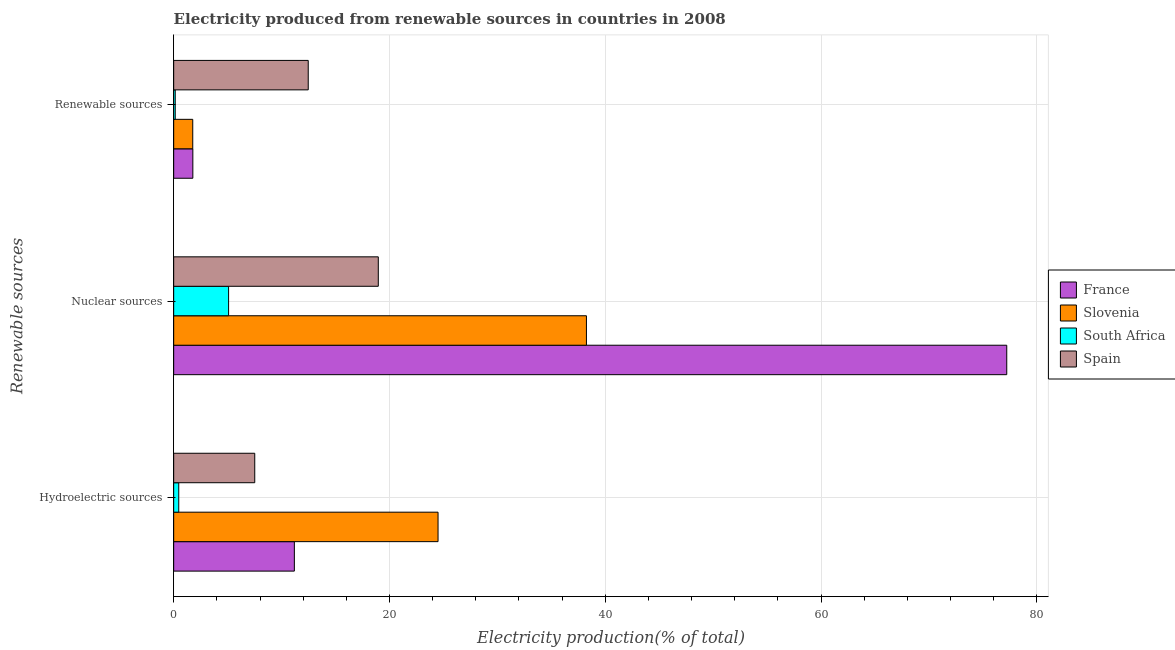How many different coloured bars are there?
Provide a short and direct response. 4. How many groups of bars are there?
Make the answer very short. 3. Are the number of bars per tick equal to the number of legend labels?
Your answer should be very brief. Yes. Are the number of bars on each tick of the Y-axis equal?
Ensure brevity in your answer.  Yes. How many bars are there on the 3rd tick from the bottom?
Give a very brief answer. 4. What is the label of the 3rd group of bars from the top?
Keep it short and to the point. Hydroelectric sources. What is the percentage of electricity produced by hydroelectric sources in France?
Offer a very short reply. 11.18. Across all countries, what is the maximum percentage of electricity produced by renewable sources?
Your answer should be very brief. 12.47. Across all countries, what is the minimum percentage of electricity produced by hydroelectric sources?
Your answer should be compact. 0.47. In which country was the percentage of electricity produced by nuclear sources maximum?
Keep it short and to the point. France. In which country was the percentage of electricity produced by nuclear sources minimum?
Offer a very short reply. South Africa. What is the total percentage of electricity produced by hydroelectric sources in the graph?
Offer a terse response. 43.67. What is the difference between the percentage of electricity produced by renewable sources in Slovenia and that in France?
Your answer should be very brief. -0.01. What is the difference between the percentage of electricity produced by nuclear sources in Slovenia and the percentage of electricity produced by renewable sources in France?
Keep it short and to the point. 36.48. What is the average percentage of electricity produced by hydroelectric sources per country?
Keep it short and to the point. 10.92. What is the difference between the percentage of electricity produced by hydroelectric sources and percentage of electricity produced by renewable sources in France?
Provide a short and direct response. 9.41. What is the ratio of the percentage of electricity produced by hydroelectric sources in South Africa to that in Slovenia?
Provide a succinct answer. 0.02. Is the difference between the percentage of electricity produced by renewable sources in Spain and France greater than the difference between the percentage of electricity produced by hydroelectric sources in Spain and France?
Provide a short and direct response. Yes. What is the difference between the highest and the second highest percentage of electricity produced by hydroelectric sources?
Your response must be concise. 13.32. What is the difference between the highest and the lowest percentage of electricity produced by renewable sources?
Offer a terse response. 12.33. In how many countries, is the percentage of electricity produced by hydroelectric sources greater than the average percentage of electricity produced by hydroelectric sources taken over all countries?
Give a very brief answer. 2. Is the sum of the percentage of electricity produced by renewable sources in South Africa and France greater than the maximum percentage of electricity produced by nuclear sources across all countries?
Your answer should be very brief. No. What does the 4th bar from the top in Hydroelectric sources represents?
Your response must be concise. France. Is it the case that in every country, the sum of the percentage of electricity produced by hydroelectric sources and percentage of electricity produced by nuclear sources is greater than the percentage of electricity produced by renewable sources?
Keep it short and to the point. Yes. Are all the bars in the graph horizontal?
Your response must be concise. Yes. What is the difference between two consecutive major ticks on the X-axis?
Your answer should be very brief. 20. Does the graph contain grids?
Make the answer very short. Yes. Where does the legend appear in the graph?
Ensure brevity in your answer.  Center right. How are the legend labels stacked?
Your response must be concise. Vertical. What is the title of the graph?
Offer a very short reply. Electricity produced from renewable sources in countries in 2008. What is the label or title of the Y-axis?
Ensure brevity in your answer.  Renewable sources. What is the Electricity production(% of total) of France in Hydroelectric sources?
Your answer should be very brief. 11.18. What is the Electricity production(% of total) in Slovenia in Hydroelectric sources?
Provide a succinct answer. 24.5. What is the Electricity production(% of total) in South Africa in Hydroelectric sources?
Offer a terse response. 0.47. What is the Electricity production(% of total) of Spain in Hydroelectric sources?
Ensure brevity in your answer.  7.51. What is the Electricity production(% of total) of France in Nuclear sources?
Offer a very short reply. 77.21. What is the Electricity production(% of total) in Slovenia in Nuclear sources?
Your answer should be very brief. 38.25. What is the Electricity production(% of total) of South Africa in Nuclear sources?
Your answer should be compact. 5.09. What is the Electricity production(% of total) of Spain in Nuclear sources?
Your answer should be very brief. 18.96. What is the Electricity production(% of total) of France in Renewable sources?
Make the answer very short. 1.78. What is the Electricity production(% of total) of Slovenia in Renewable sources?
Provide a succinct answer. 1.77. What is the Electricity production(% of total) in South Africa in Renewable sources?
Offer a very short reply. 0.14. What is the Electricity production(% of total) in Spain in Renewable sources?
Keep it short and to the point. 12.47. Across all Renewable sources, what is the maximum Electricity production(% of total) of France?
Provide a short and direct response. 77.21. Across all Renewable sources, what is the maximum Electricity production(% of total) of Slovenia?
Offer a very short reply. 38.25. Across all Renewable sources, what is the maximum Electricity production(% of total) of South Africa?
Make the answer very short. 5.09. Across all Renewable sources, what is the maximum Electricity production(% of total) of Spain?
Provide a succinct answer. 18.96. Across all Renewable sources, what is the minimum Electricity production(% of total) of France?
Ensure brevity in your answer.  1.78. Across all Renewable sources, what is the minimum Electricity production(% of total) of Slovenia?
Your answer should be compact. 1.77. Across all Renewable sources, what is the minimum Electricity production(% of total) of South Africa?
Your answer should be compact. 0.14. Across all Renewable sources, what is the minimum Electricity production(% of total) in Spain?
Give a very brief answer. 7.51. What is the total Electricity production(% of total) in France in the graph?
Your answer should be very brief. 90.17. What is the total Electricity production(% of total) of Slovenia in the graph?
Your answer should be compact. 64.52. What is the total Electricity production(% of total) in South Africa in the graph?
Offer a terse response. 5.7. What is the total Electricity production(% of total) of Spain in the graph?
Offer a terse response. 38.95. What is the difference between the Electricity production(% of total) in France in Hydroelectric sources and that in Nuclear sources?
Provide a succinct answer. -66.02. What is the difference between the Electricity production(% of total) of Slovenia in Hydroelectric sources and that in Nuclear sources?
Your answer should be compact. -13.75. What is the difference between the Electricity production(% of total) in South Africa in Hydroelectric sources and that in Nuclear sources?
Keep it short and to the point. -4.62. What is the difference between the Electricity production(% of total) in Spain in Hydroelectric sources and that in Nuclear sources?
Your answer should be compact. -11.45. What is the difference between the Electricity production(% of total) in France in Hydroelectric sources and that in Renewable sources?
Keep it short and to the point. 9.41. What is the difference between the Electricity production(% of total) in Slovenia in Hydroelectric sources and that in Renewable sources?
Offer a terse response. 22.73. What is the difference between the Electricity production(% of total) of South Africa in Hydroelectric sources and that in Renewable sources?
Your answer should be compact. 0.33. What is the difference between the Electricity production(% of total) of Spain in Hydroelectric sources and that in Renewable sources?
Your answer should be very brief. -4.96. What is the difference between the Electricity production(% of total) of France in Nuclear sources and that in Renewable sources?
Give a very brief answer. 75.43. What is the difference between the Electricity production(% of total) in Slovenia in Nuclear sources and that in Renewable sources?
Your response must be concise. 36.48. What is the difference between the Electricity production(% of total) of South Africa in Nuclear sources and that in Renewable sources?
Your answer should be very brief. 4.94. What is the difference between the Electricity production(% of total) in Spain in Nuclear sources and that in Renewable sources?
Make the answer very short. 6.49. What is the difference between the Electricity production(% of total) of France in Hydroelectric sources and the Electricity production(% of total) of Slovenia in Nuclear sources?
Offer a very short reply. -27.07. What is the difference between the Electricity production(% of total) of France in Hydroelectric sources and the Electricity production(% of total) of South Africa in Nuclear sources?
Give a very brief answer. 6.09. What is the difference between the Electricity production(% of total) of France in Hydroelectric sources and the Electricity production(% of total) of Spain in Nuclear sources?
Offer a very short reply. -7.78. What is the difference between the Electricity production(% of total) of Slovenia in Hydroelectric sources and the Electricity production(% of total) of South Africa in Nuclear sources?
Your response must be concise. 19.41. What is the difference between the Electricity production(% of total) of Slovenia in Hydroelectric sources and the Electricity production(% of total) of Spain in Nuclear sources?
Your response must be concise. 5.54. What is the difference between the Electricity production(% of total) in South Africa in Hydroelectric sources and the Electricity production(% of total) in Spain in Nuclear sources?
Your answer should be very brief. -18.49. What is the difference between the Electricity production(% of total) in France in Hydroelectric sources and the Electricity production(% of total) in Slovenia in Renewable sources?
Your answer should be very brief. 9.42. What is the difference between the Electricity production(% of total) in France in Hydroelectric sources and the Electricity production(% of total) in South Africa in Renewable sources?
Provide a succinct answer. 11.04. What is the difference between the Electricity production(% of total) of France in Hydroelectric sources and the Electricity production(% of total) of Spain in Renewable sources?
Keep it short and to the point. -1.29. What is the difference between the Electricity production(% of total) in Slovenia in Hydroelectric sources and the Electricity production(% of total) in South Africa in Renewable sources?
Your response must be concise. 24.36. What is the difference between the Electricity production(% of total) in Slovenia in Hydroelectric sources and the Electricity production(% of total) in Spain in Renewable sources?
Provide a short and direct response. 12.03. What is the difference between the Electricity production(% of total) of South Africa in Hydroelectric sources and the Electricity production(% of total) of Spain in Renewable sources?
Provide a short and direct response. -12. What is the difference between the Electricity production(% of total) in France in Nuclear sources and the Electricity production(% of total) in Slovenia in Renewable sources?
Your answer should be compact. 75.44. What is the difference between the Electricity production(% of total) of France in Nuclear sources and the Electricity production(% of total) of South Africa in Renewable sources?
Offer a terse response. 77.06. What is the difference between the Electricity production(% of total) of France in Nuclear sources and the Electricity production(% of total) of Spain in Renewable sources?
Provide a short and direct response. 64.74. What is the difference between the Electricity production(% of total) in Slovenia in Nuclear sources and the Electricity production(% of total) in South Africa in Renewable sources?
Make the answer very short. 38.11. What is the difference between the Electricity production(% of total) in Slovenia in Nuclear sources and the Electricity production(% of total) in Spain in Renewable sources?
Your answer should be compact. 25.78. What is the difference between the Electricity production(% of total) in South Africa in Nuclear sources and the Electricity production(% of total) in Spain in Renewable sources?
Provide a succinct answer. -7.38. What is the average Electricity production(% of total) in France per Renewable sources?
Your response must be concise. 30.06. What is the average Electricity production(% of total) in Slovenia per Renewable sources?
Ensure brevity in your answer.  21.51. What is the average Electricity production(% of total) of South Africa per Renewable sources?
Your response must be concise. 1.9. What is the average Electricity production(% of total) in Spain per Renewable sources?
Provide a succinct answer. 12.98. What is the difference between the Electricity production(% of total) of France and Electricity production(% of total) of Slovenia in Hydroelectric sources?
Your answer should be very brief. -13.32. What is the difference between the Electricity production(% of total) of France and Electricity production(% of total) of South Africa in Hydroelectric sources?
Your answer should be compact. 10.71. What is the difference between the Electricity production(% of total) in France and Electricity production(% of total) in Spain in Hydroelectric sources?
Provide a short and direct response. 3.67. What is the difference between the Electricity production(% of total) in Slovenia and Electricity production(% of total) in South Africa in Hydroelectric sources?
Provide a short and direct response. 24.03. What is the difference between the Electricity production(% of total) in Slovenia and Electricity production(% of total) in Spain in Hydroelectric sources?
Offer a terse response. 16.99. What is the difference between the Electricity production(% of total) of South Africa and Electricity production(% of total) of Spain in Hydroelectric sources?
Keep it short and to the point. -7.04. What is the difference between the Electricity production(% of total) in France and Electricity production(% of total) in Slovenia in Nuclear sources?
Make the answer very short. 38.95. What is the difference between the Electricity production(% of total) in France and Electricity production(% of total) in South Africa in Nuclear sources?
Your answer should be very brief. 72.12. What is the difference between the Electricity production(% of total) of France and Electricity production(% of total) of Spain in Nuclear sources?
Your answer should be very brief. 58.24. What is the difference between the Electricity production(% of total) in Slovenia and Electricity production(% of total) in South Africa in Nuclear sources?
Keep it short and to the point. 33.16. What is the difference between the Electricity production(% of total) in Slovenia and Electricity production(% of total) in Spain in Nuclear sources?
Provide a succinct answer. 19.29. What is the difference between the Electricity production(% of total) in South Africa and Electricity production(% of total) in Spain in Nuclear sources?
Keep it short and to the point. -13.87. What is the difference between the Electricity production(% of total) of France and Electricity production(% of total) of Slovenia in Renewable sources?
Offer a very short reply. 0.01. What is the difference between the Electricity production(% of total) of France and Electricity production(% of total) of South Africa in Renewable sources?
Give a very brief answer. 1.63. What is the difference between the Electricity production(% of total) in France and Electricity production(% of total) in Spain in Renewable sources?
Your answer should be very brief. -10.69. What is the difference between the Electricity production(% of total) in Slovenia and Electricity production(% of total) in South Africa in Renewable sources?
Offer a very short reply. 1.62. What is the difference between the Electricity production(% of total) in Slovenia and Electricity production(% of total) in Spain in Renewable sources?
Make the answer very short. -10.7. What is the difference between the Electricity production(% of total) of South Africa and Electricity production(% of total) of Spain in Renewable sources?
Your answer should be very brief. -12.33. What is the ratio of the Electricity production(% of total) in France in Hydroelectric sources to that in Nuclear sources?
Offer a terse response. 0.14. What is the ratio of the Electricity production(% of total) in Slovenia in Hydroelectric sources to that in Nuclear sources?
Provide a succinct answer. 0.64. What is the ratio of the Electricity production(% of total) in South Africa in Hydroelectric sources to that in Nuclear sources?
Provide a short and direct response. 0.09. What is the ratio of the Electricity production(% of total) of Spain in Hydroelectric sources to that in Nuclear sources?
Provide a short and direct response. 0.4. What is the ratio of the Electricity production(% of total) of France in Hydroelectric sources to that in Renewable sources?
Ensure brevity in your answer.  6.29. What is the ratio of the Electricity production(% of total) in Slovenia in Hydroelectric sources to that in Renewable sources?
Your answer should be very brief. 13.86. What is the ratio of the Electricity production(% of total) in South Africa in Hydroelectric sources to that in Renewable sources?
Your answer should be very brief. 3.26. What is the ratio of the Electricity production(% of total) in Spain in Hydroelectric sources to that in Renewable sources?
Ensure brevity in your answer.  0.6. What is the ratio of the Electricity production(% of total) of France in Nuclear sources to that in Renewable sources?
Provide a succinct answer. 43.45. What is the ratio of the Electricity production(% of total) in Slovenia in Nuclear sources to that in Renewable sources?
Make the answer very short. 21.63. What is the ratio of the Electricity production(% of total) of South Africa in Nuclear sources to that in Renewable sources?
Offer a very short reply. 35.24. What is the ratio of the Electricity production(% of total) of Spain in Nuclear sources to that in Renewable sources?
Provide a succinct answer. 1.52. What is the difference between the highest and the second highest Electricity production(% of total) in France?
Your response must be concise. 66.02. What is the difference between the highest and the second highest Electricity production(% of total) in Slovenia?
Your answer should be compact. 13.75. What is the difference between the highest and the second highest Electricity production(% of total) in South Africa?
Provide a succinct answer. 4.62. What is the difference between the highest and the second highest Electricity production(% of total) of Spain?
Offer a very short reply. 6.49. What is the difference between the highest and the lowest Electricity production(% of total) in France?
Provide a succinct answer. 75.43. What is the difference between the highest and the lowest Electricity production(% of total) of Slovenia?
Your response must be concise. 36.48. What is the difference between the highest and the lowest Electricity production(% of total) of South Africa?
Keep it short and to the point. 4.94. What is the difference between the highest and the lowest Electricity production(% of total) in Spain?
Provide a succinct answer. 11.45. 